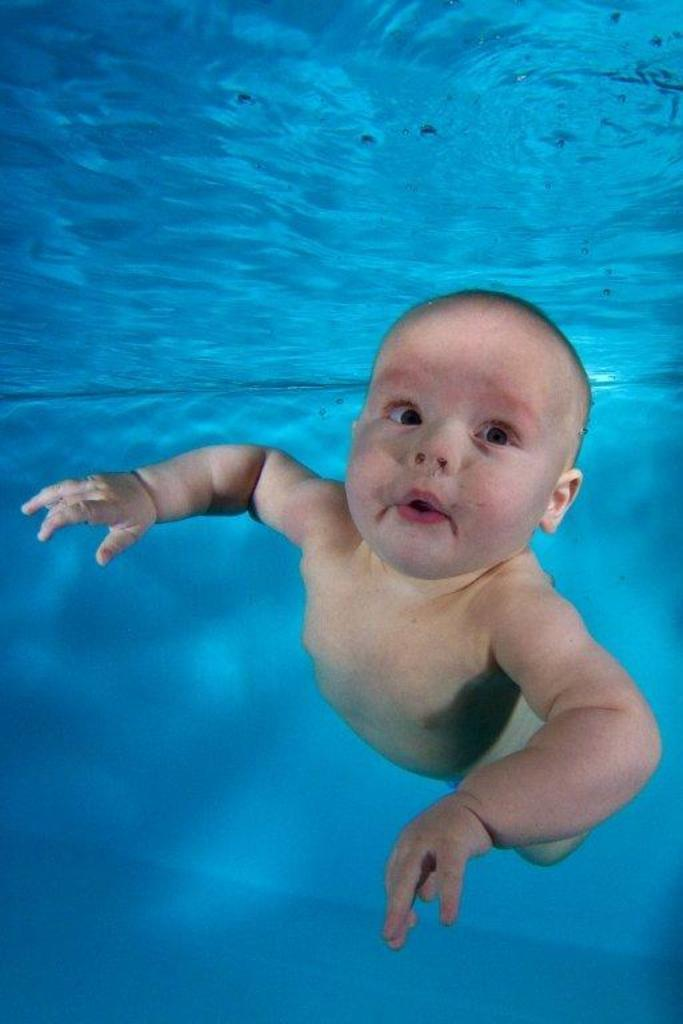What is the main subject of the image? The main subject of the image is an inside view of water. Is there anything else visible in the image besides the water? Yes, there is a baby in front in the image. What type of rice is being cooked in the image? There is no rice present in the image; it features an inside view of water and a baby in front. Can you describe the woman's outfit in the image? There is no woman present in the image; it only shows an inside view of water and a baby in front. 